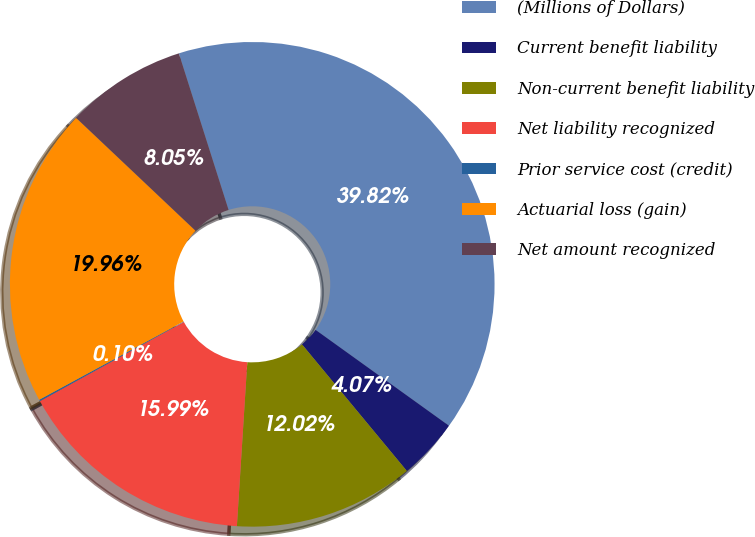Convert chart. <chart><loc_0><loc_0><loc_500><loc_500><pie_chart><fcel>(Millions of Dollars)<fcel>Current benefit liability<fcel>Non-current benefit liability<fcel>Net liability recognized<fcel>Prior service cost (credit)<fcel>Actuarial loss (gain)<fcel>Net amount recognized<nl><fcel>39.82%<fcel>4.07%<fcel>12.02%<fcel>15.99%<fcel>0.1%<fcel>19.96%<fcel>8.05%<nl></chart> 